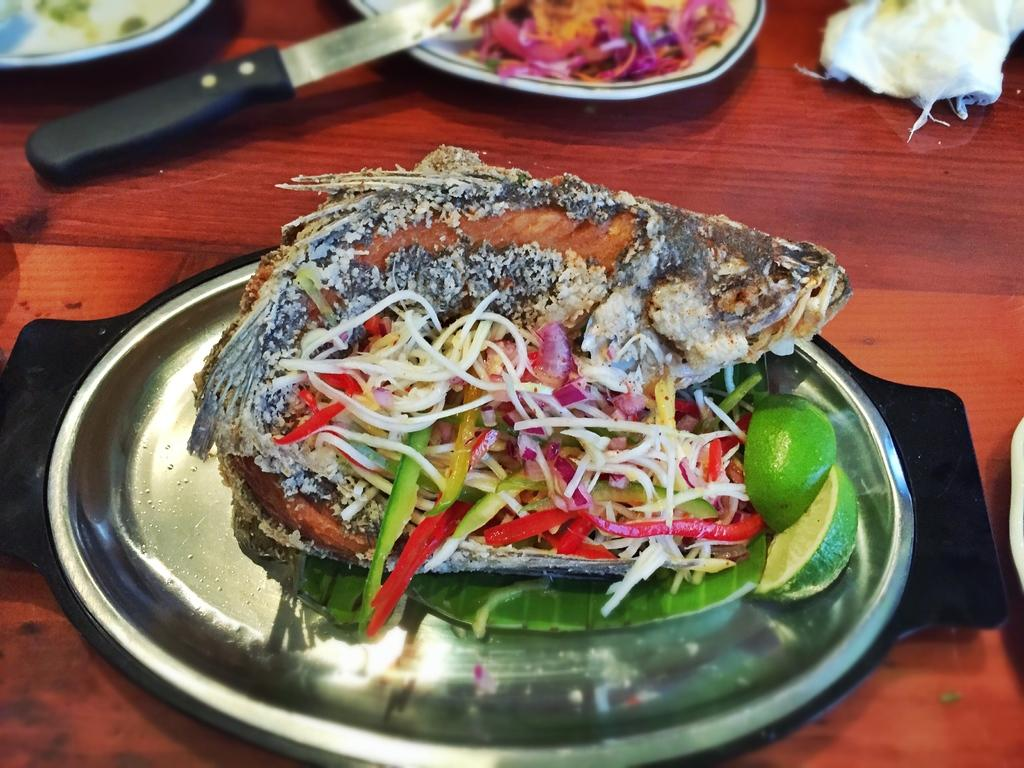What type of utensil can be seen in the image? There is a knife in the image. What is on the plates in the image? There are plates with food items in the image. Can you describe any other objects in the image? There are other objects in the image, but their specific details are not mentioned in the provided facts. What type of surface is visible in the image? The wooden surface is present in the image. What type of baseball equipment can be seen in the image? There is no baseball equipment present in the image. Can you describe the toothbrush used by the person in the image? There is no toothbrush or person present in the image. 